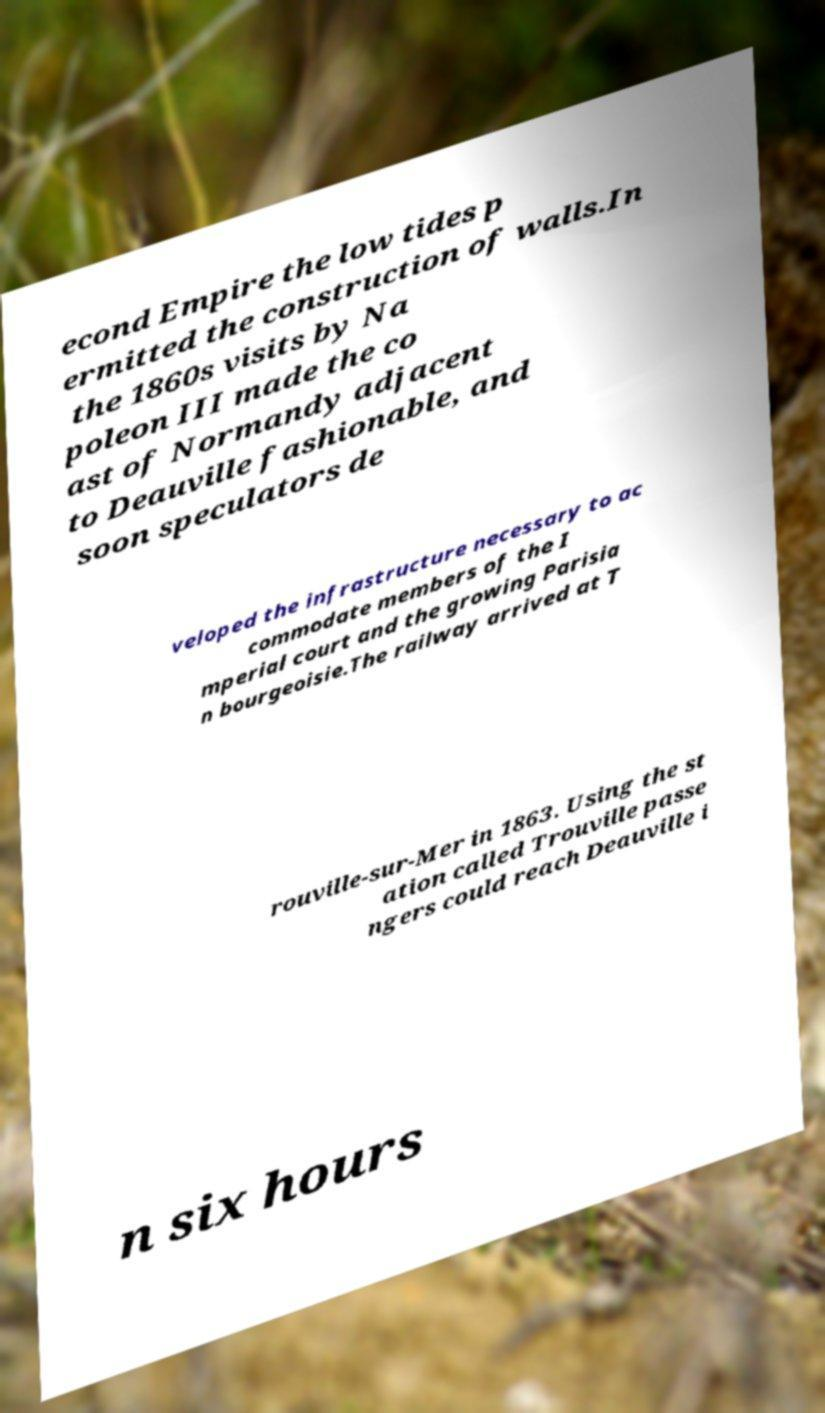Can you accurately transcribe the text from the provided image for me? econd Empire the low tides p ermitted the construction of walls.In the 1860s visits by Na poleon III made the co ast of Normandy adjacent to Deauville fashionable, and soon speculators de veloped the infrastructure necessary to ac commodate members of the I mperial court and the growing Parisia n bourgeoisie.The railway arrived at T rouville-sur-Mer in 1863. Using the st ation called Trouville passe ngers could reach Deauville i n six hours 